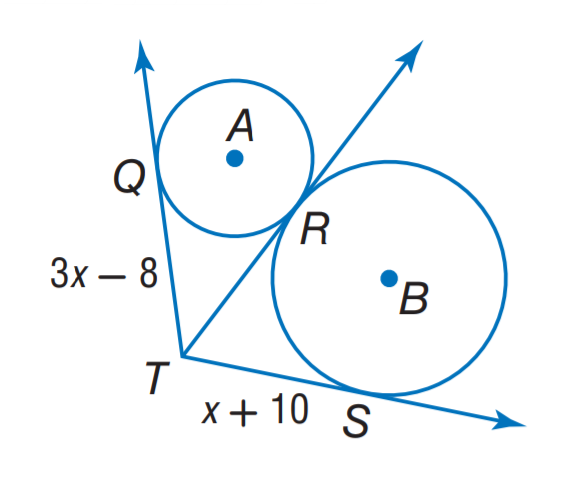Answer the mathemtical geometry problem and directly provide the correct option letter.
Question: The segment is tangent to the circle. Find x.
Choices: A: 7 B: 8 C: 9 D: 10 C 